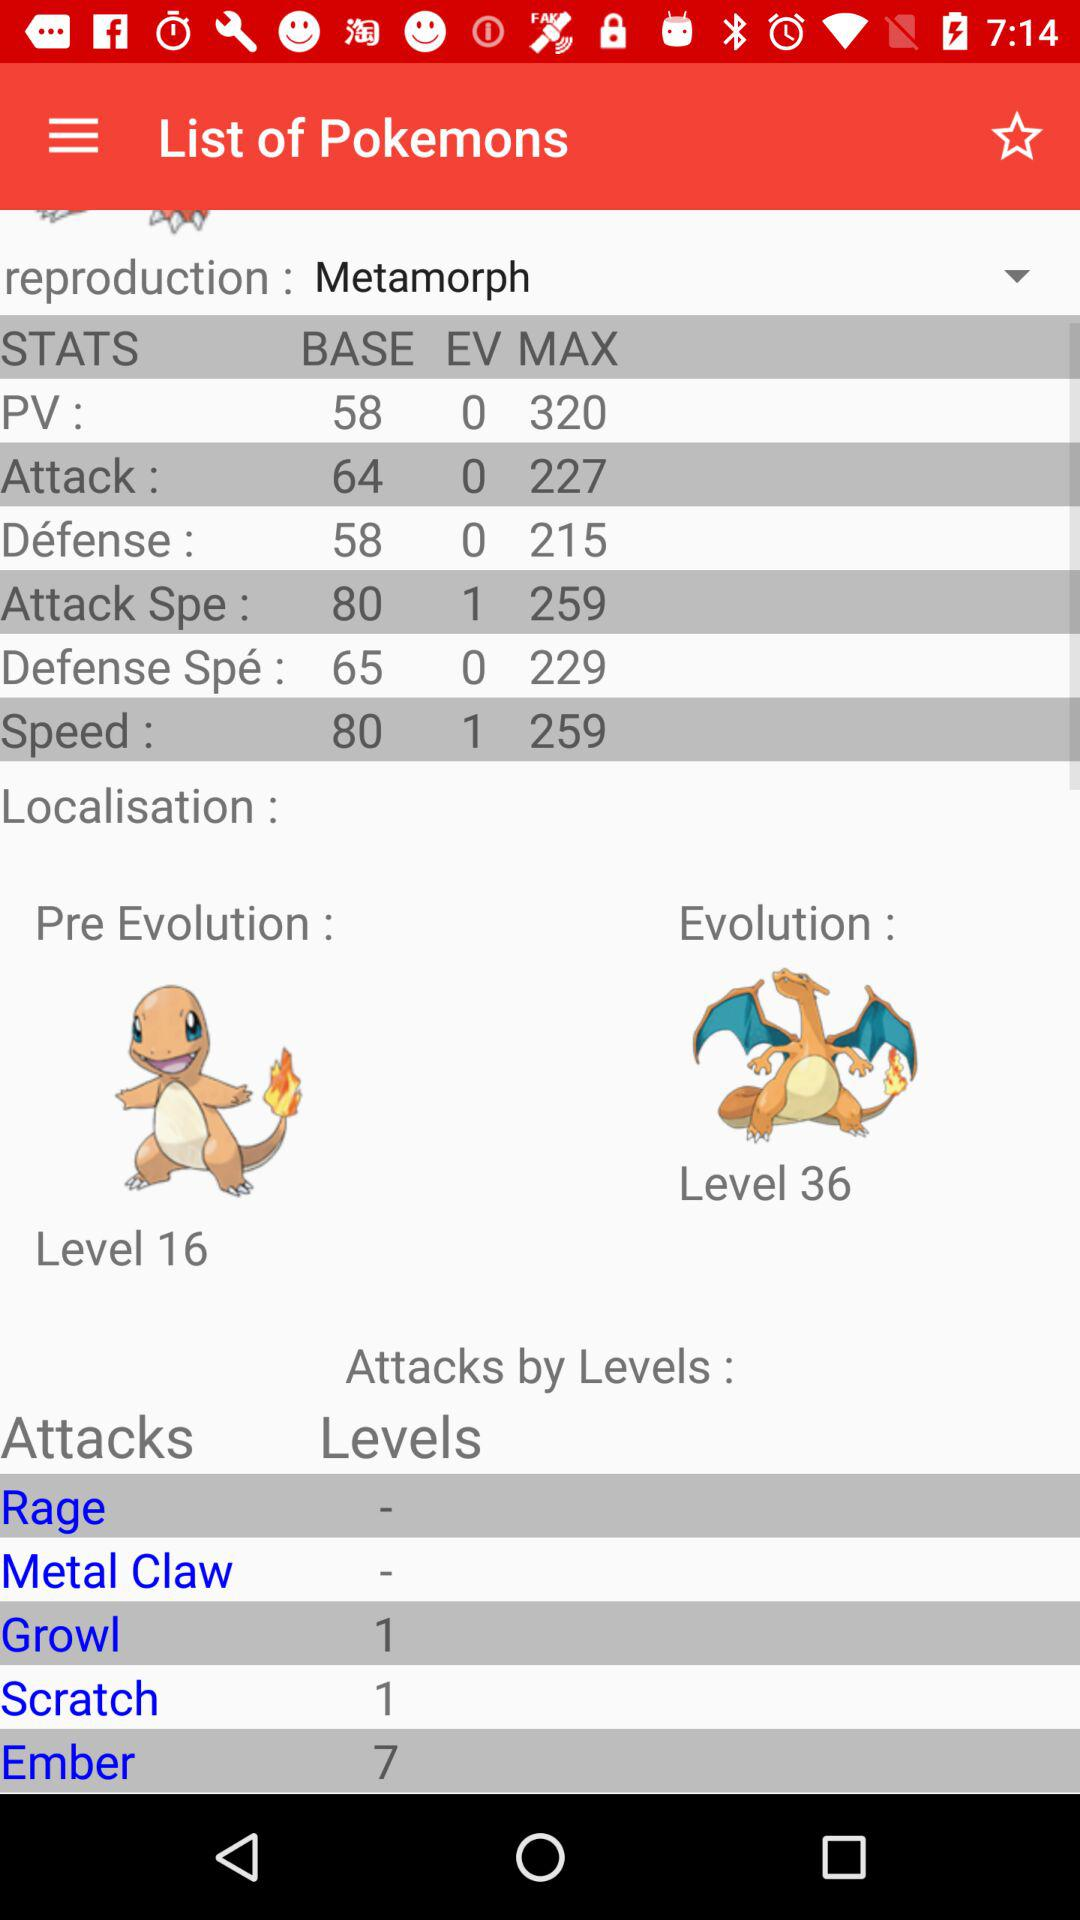What is the EV of attack? The EV of attack is 0. 